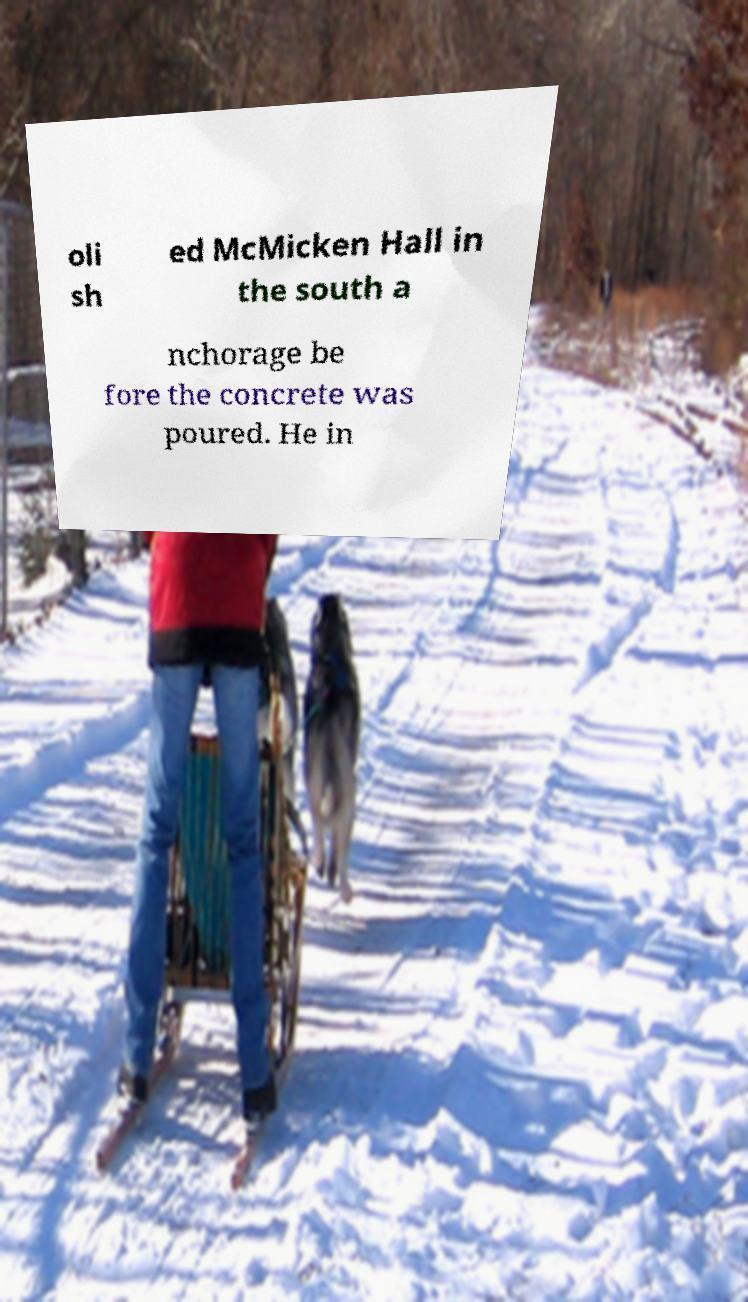What messages or text are displayed in this image? I need them in a readable, typed format. oli sh ed McMicken Hall in the south a nchorage be fore the concrete was poured. He in 